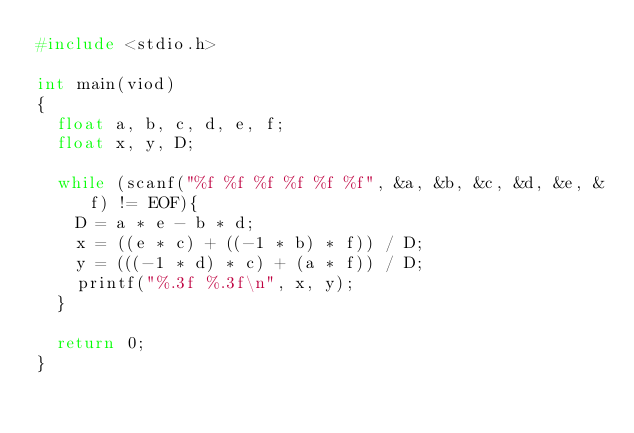Convert code to text. <code><loc_0><loc_0><loc_500><loc_500><_C_>#include <stdio.h>

int main(viod)
{
	float a, b, c, d, e, f;
	float x, y, D;
	
	while (scanf("%f %f %f %f %f %f", &a, &b, &c, &d, &e, &f) != EOF){
		D = a * e - b * d;
		x = ((e * c) + ((-1 * b) * f)) / D;
		y = (((-1 * d) * c) + (a * f)) / D;
		printf("%.3f %.3f\n", x, y);
	}
	
	return 0;
}</code> 